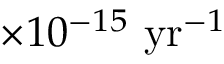Convert formula to latex. <formula><loc_0><loc_0><loc_500><loc_500>\times 1 0 ^ { - 1 5 } \ y r ^ { - 1 }</formula> 